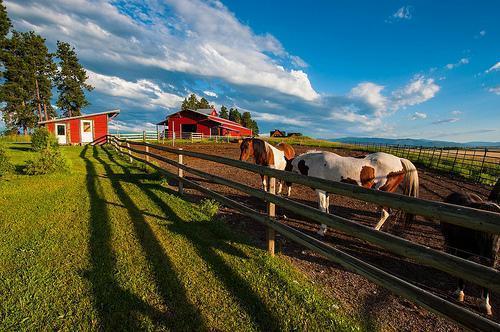How many brown and white horses?
Give a very brief answer. 2. 